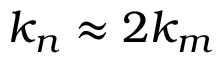<formula> <loc_0><loc_0><loc_500><loc_500>k _ { n } \approx 2 k _ { m }</formula> 